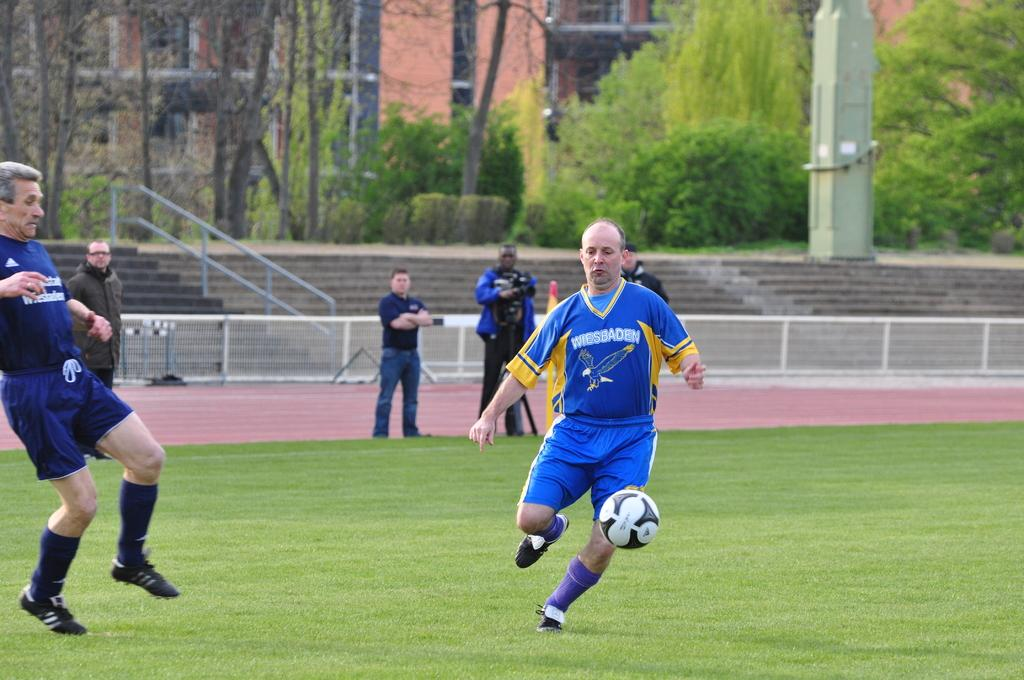What are the two people in the image doing? The two people in the image are playing football. Are there any other people in the image besides the ones playing football? Yes, other persons are watching the football game. What can be seen in the background of the image? There is a building visible in the image, as well as trees. Are there any architectural features in the image? Yes, there are steps in the image. What type of shock can be seen affecting the hen in the image? There is no hen present in the image, so it is not possible to determine if any shock is affecting it. 